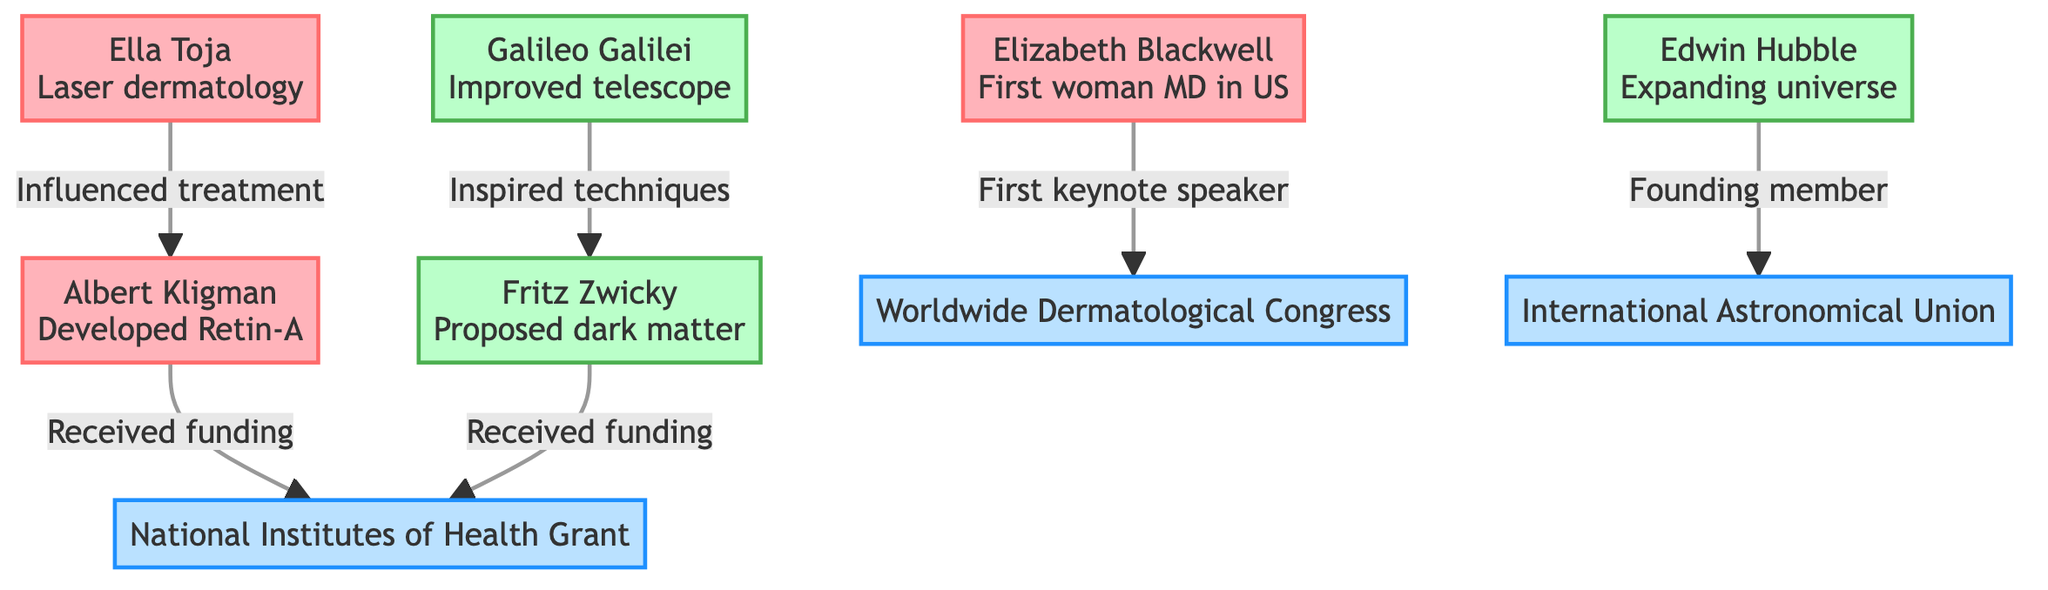What is Albert Kligman's major contribution? Albert Kligman is credited with developing Retin-A, which is indicated in the diagram next to his name.
Answer: Developed Retin-A How many influential figures in dermatology are listed in the diagram? There are three notable dermatologists listed in the diagram: Albert Kligman, Ella Toja, and Elizabeth Blackwell.
Answer: Three Who received funding from the National Institutes of Health Grant? Both Albert Kligman and Fritz Zwicky are indicated in the diagram as having received funding from the National Institutes of Health Grant, connected by arrows to this organization node.
Answer: Albert Kligman and Fritz Zwicky Which astronomer is known for proposing dark matter? Fritz Zwicky is identified in the diagram as the one who proposed dark matter, as indicated next to his name.
Answer: Fritz Zwicky What relationship does Ella Toja have with Albert Kligman? Ella Toja influenced treatment, which is shown by the arrow pointing from Ella Toja to Albert Kligman in the diagram.
Answer: Influenced treatment Which historical figure was the first keynote speaker for the Worldwide Dermatological Congress? The diagram indicates that Elizabeth Blackwell was the first keynote speaker for the Worldwide Dermatological Congress, as stated in her node.
Answer: Elizabeth Blackwell How many organizations are represented in the diagram? There are two organizations shown in the diagram: the National Institutes of Health Grant and the Worldwide Dermatological Congress.
Answer: Two What did Edwin Hubble contribute to astronomy? Edwin Hubble contributed by discovering the expanding universe, as highlighted in the diagram next to his name.
Answer: Expanding universe Who inspired techniques that influenced Fritz Zwicky? Galileo Galilei is noted in the diagram as inspiring techniques that influenced Fritz Zwicky, connected by an arrow.
Answer: Galileo Galilei Is there a connection between the International Astronomical Union and Edwin Hubble? Yes, the diagram shows that Edwin Hubble is a founding member of the International Astronomical Union, as indicated by the arrow linking them.
Answer: Yes 